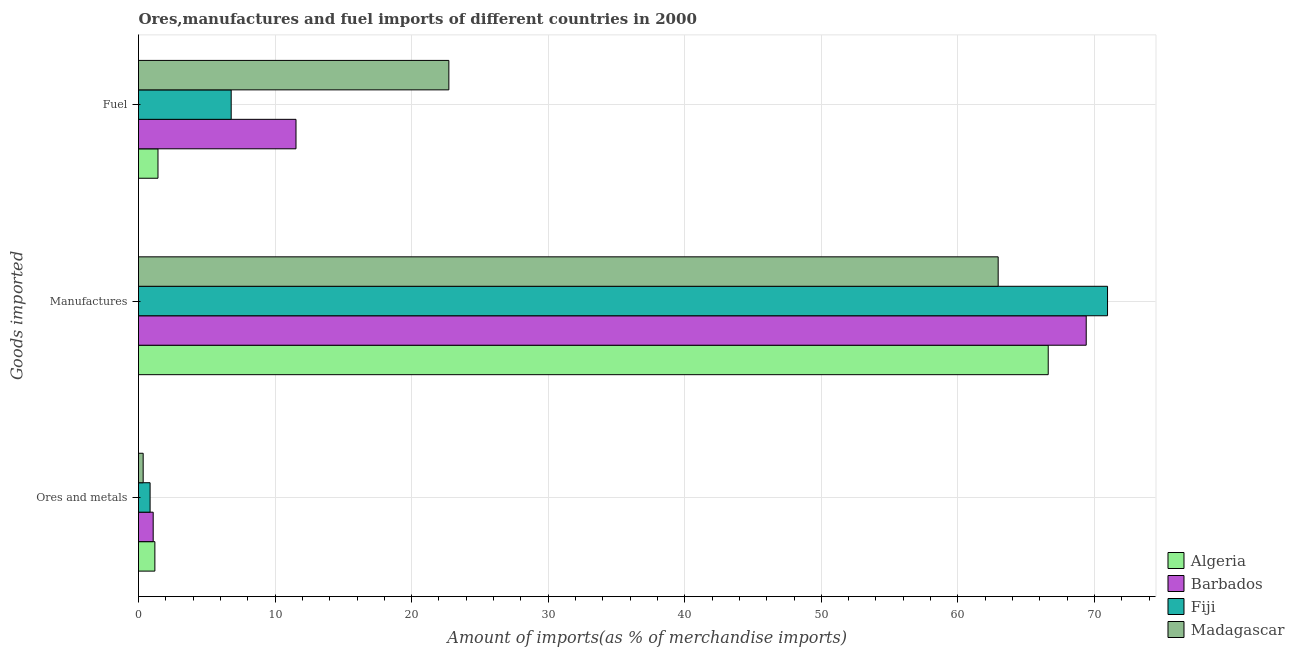Are the number of bars per tick equal to the number of legend labels?
Make the answer very short. Yes. How many bars are there on the 1st tick from the top?
Give a very brief answer. 4. What is the label of the 3rd group of bars from the top?
Give a very brief answer. Ores and metals. What is the percentage of ores and metals imports in Algeria?
Provide a succinct answer. 1.2. Across all countries, what is the maximum percentage of fuel imports?
Your answer should be very brief. 22.73. Across all countries, what is the minimum percentage of fuel imports?
Provide a succinct answer. 1.43. In which country was the percentage of fuel imports maximum?
Your answer should be very brief. Madagascar. In which country was the percentage of ores and metals imports minimum?
Make the answer very short. Madagascar. What is the total percentage of fuel imports in the graph?
Keep it short and to the point. 42.47. What is the difference between the percentage of manufactures imports in Fiji and that in Madagascar?
Give a very brief answer. 8.01. What is the difference between the percentage of manufactures imports in Madagascar and the percentage of fuel imports in Barbados?
Your answer should be compact. 51.42. What is the average percentage of manufactures imports per country?
Provide a short and direct response. 67.48. What is the difference between the percentage of fuel imports and percentage of manufactures imports in Fiji?
Your response must be concise. -64.17. In how many countries, is the percentage of fuel imports greater than 46 %?
Offer a terse response. 0. What is the ratio of the percentage of fuel imports in Madagascar to that in Algeria?
Offer a terse response. 15.93. Is the difference between the percentage of manufactures imports in Barbados and Fiji greater than the difference between the percentage of fuel imports in Barbados and Fiji?
Your answer should be very brief. No. What is the difference between the highest and the second highest percentage of ores and metals imports?
Your answer should be compact. 0.12. What is the difference between the highest and the lowest percentage of fuel imports?
Give a very brief answer. 21.3. Is the sum of the percentage of manufactures imports in Algeria and Fiji greater than the maximum percentage of fuel imports across all countries?
Provide a succinct answer. Yes. What does the 2nd bar from the top in Fuel represents?
Your answer should be compact. Fiji. What does the 2nd bar from the bottom in Ores and metals represents?
Give a very brief answer. Barbados. How many bars are there?
Give a very brief answer. 12. Are all the bars in the graph horizontal?
Make the answer very short. Yes. How many countries are there in the graph?
Offer a terse response. 4. Does the graph contain any zero values?
Offer a terse response. No. How are the legend labels stacked?
Your answer should be compact. Vertical. What is the title of the graph?
Your answer should be compact. Ores,manufactures and fuel imports of different countries in 2000. What is the label or title of the X-axis?
Offer a terse response. Amount of imports(as % of merchandise imports). What is the label or title of the Y-axis?
Provide a short and direct response. Goods imported. What is the Amount of imports(as % of merchandise imports) in Algeria in Ores and metals?
Give a very brief answer. 1.2. What is the Amount of imports(as % of merchandise imports) in Barbados in Ores and metals?
Keep it short and to the point. 1.07. What is the Amount of imports(as % of merchandise imports) in Fiji in Ores and metals?
Ensure brevity in your answer.  0.85. What is the Amount of imports(as % of merchandise imports) in Madagascar in Ores and metals?
Your answer should be compact. 0.34. What is the Amount of imports(as % of merchandise imports) of Algeria in Manufactures?
Offer a very short reply. 66.61. What is the Amount of imports(as % of merchandise imports) of Barbados in Manufactures?
Give a very brief answer. 69.4. What is the Amount of imports(as % of merchandise imports) in Fiji in Manufactures?
Keep it short and to the point. 70.96. What is the Amount of imports(as % of merchandise imports) of Madagascar in Manufactures?
Give a very brief answer. 62.95. What is the Amount of imports(as % of merchandise imports) of Algeria in Fuel?
Your answer should be compact. 1.43. What is the Amount of imports(as % of merchandise imports) in Barbados in Fuel?
Ensure brevity in your answer.  11.53. What is the Amount of imports(as % of merchandise imports) in Fiji in Fuel?
Your response must be concise. 6.79. What is the Amount of imports(as % of merchandise imports) in Madagascar in Fuel?
Your answer should be compact. 22.73. Across all Goods imported, what is the maximum Amount of imports(as % of merchandise imports) of Algeria?
Provide a short and direct response. 66.61. Across all Goods imported, what is the maximum Amount of imports(as % of merchandise imports) of Barbados?
Keep it short and to the point. 69.4. Across all Goods imported, what is the maximum Amount of imports(as % of merchandise imports) of Fiji?
Provide a succinct answer. 70.96. Across all Goods imported, what is the maximum Amount of imports(as % of merchandise imports) of Madagascar?
Your answer should be very brief. 62.95. Across all Goods imported, what is the minimum Amount of imports(as % of merchandise imports) of Algeria?
Provide a succinct answer. 1.2. Across all Goods imported, what is the minimum Amount of imports(as % of merchandise imports) of Barbados?
Your answer should be compact. 1.07. Across all Goods imported, what is the minimum Amount of imports(as % of merchandise imports) of Fiji?
Provide a short and direct response. 0.85. Across all Goods imported, what is the minimum Amount of imports(as % of merchandise imports) of Madagascar?
Ensure brevity in your answer.  0.34. What is the total Amount of imports(as % of merchandise imports) of Algeria in the graph?
Offer a terse response. 69.24. What is the total Amount of imports(as % of merchandise imports) in Barbados in the graph?
Make the answer very short. 82. What is the total Amount of imports(as % of merchandise imports) in Fiji in the graph?
Give a very brief answer. 78.59. What is the total Amount of imports(as % of merchandise imports) in Madagascar in the graph?
Provide a short and direct response. 86.02. What is the difference between the Amount of imports(as % of merchandise imports) of Algeria in Ores and metals and that in Manufactures?
Provide a succinct answer. -65.42. What is the difference between the Amount of imports(as % of merchandise imports) of Barbados in Ores and metals and that in Manufactures?
Give a very brief answer. -68.32. What is the difference between the Amount of imports(as % of merchandise imports) in Fiji in Ores and metals and that in Manufactures?
Keep it short and to the point. -70.11. What is the difference between the Amount of imports(as % of merchandise imports) of Madagascar in Ores and metals and that in Manufactures?
Your answer should be very brief. -62.61. What is the difference between the Amount of imports(as % of merchandise imports) in Algeria in Ores and metals and that in Fuel?
Provide a succinct answer. -0.23. What is the difference between the Amount of imports(as % of merchandise imports) of Barbados in Ores and metals and that in Fuel?
Ensure brevity in your answer.  -10.46. What is the difference between the Amount of imports(as % of merchandise imports) in Fiji in Ores and metals and that in Fuel?
Your answer should be very brief. -5.94. What is the difference between the Amount of imports(as % of merchandise imports) in Madagascar in Ores and metals and that in Fuel?
Your answer should be very brief. -22.38. What is the difference between the Amount of imports(as % of merchandise imports) of Algeria in Manufactures and that in Fuel?
Offer a terse response. 65.19. What is the difference between the Amount of imports(as % of merchandise imports) of Barbados in Manufactures and that in Fuel?
Provide a succinct answer. 57.86. What is the difference between the Amount of imports(as % of merchandise imports) of Fiji in Manufactures and that in Fuel?
Ensure brevity in your answer.  64.17. What is the difference between the Amount of imports(as % of merchandise imports) of Madagascar in Manufactures and that in Fuel?
Keep it short and to the point. 40.22. What is the difference between the Amount of imports(as % of merchandise imports) of Algeria in Ores and metals and the Amount of imports(as % of merchandise imports) of Barbados in Manufactures?
Your answer should be compact. -68.2. What is the difference between the Amount of imports(as % of merchandise imports) of Algeria in Ores and metals and the Amount of imports(as % of merchandise imports) of Fiji in Manufactures?
Ensure brevity in your answer.  -69.76. What is the difference between the Amount of imports(as % of merchandise imports) in Algeria in Ores and metals and the Amount of imports(as % of merchandise imports) in Madagascar in Manufactures?
Keep it short and to the point. -61.75. What is the difference between the Amount of imports(as % of merchandise imports) of Barbados in Ores and metals and the Amount of imports(as % of merchandise imports) of Fiji in Manufactures?
Make the answer very short. -69.88. What is the difference between the Amount of imports(as % of merchandise imports) of Barbados in Ores and metals and the Amount of imports(as % of merchandise imports) of Madagascar in Manufactures?
Your answer should be very brief. -61.88. What is the difference between the Amount of imports(as % of merchandise imports) in Fiji in Ores and metals and the Amount of imports(as % of merchandise imports) in Madagascar in Manufactures?
Provide a succinct answer. -62.1. What is the difference between the Amount of imports(as % of merchandise imports) in Algeria in Ores and metals and the Amount of imports(as % of merchandise imports) in Barbados in Fuel?
Offer a terse response. -10.33. What is the difference between the Amount of imports(as % of merchandise imports) in Algeria in Ores and metals and the Amount of imports(as % of merchandise imports) in Fiji in Fuel?
Your answer should be very brief. -5.59. What is the difference between the Amount of imports(as % of merchandise imports) in Algeria in Ores and metals and the Amount of imports(as % of merchandise imports) in Madagascar in Fuel?
Offer a terse response. -21.53. What is the difference between the Amount of imports(as % of merchandise imports) in Barbados in Ores and metals and the Amount of imports(as % of merchandise imports) in Fiji in Fuel?
Provide a succinct answer. -5.71. What is the difference between the Amount of imports(as % of merchandise imports) of Barbados in Ores and metals and the Amount of imports(as % of merchandise imports) of Madagascar in Fuel?
Offer a terse response. -21.65. What is the difference between the Amount of imports(as % of merchandise imports) of Fiji in Ores and metals and the Amount of imports(as % of merchandise imports) of Madagascar in Fuel?
Provide a succinct answer. -21.88. What is the difference between the Amount of imports(as % of merchandise imports) in Algeria in Manufactures and the Amount of imports(as % of merchandise imports) in Barbados in Fuel?
Provide a short and direct response. 55.08. What is the difference between the Amount of imports(as % of merchandise imports) of Algeria in Manufactures and the Amount of imports(as % of merchandise imports) of Fiji in Fuel?
Offer a terse response. 59.83. What is the difference between the Amount of imports(as % of merchandise imports) in Algeria in Manufactures and the Amount of imports(as % of merchandise imports) in Madagascar in Fuel?
Ensure brevity in your answer.  43.89. What is the difference between the Amount of imports(as % of merchandise imports) in Barbados in Manufactures and the Amount of imports(as % of merchandise imports) in Fiji in Fuel?
Provide a short and direct response. 62.61. What is the difference between the Amount of imports(as % of merchandise imports) of Barbados in Manufactures and the Amount of imports(as % of merchandise imports) of Madagascar in Fuel?
Your answer should be very brief. 46.67. What is the difference between the Amount of imports(as % of merchandise imports) in Fiji in Manufactures and the Amount of imports(as % of merchandise imports) in Madagascar in Fuel?
Keep it short and to the point. 48.23. What is the average Amount of imports(as % of merchandise imports) of Algeria per Goods imported?
Provide a short and direct response. 23.08. What is the average Amount of imports(as % of merchandise imports) in Barbados per Goods imported?
Ensure brevity in your answer.  27.33. What is the average Amount of imports(as % of merchandise imports) in Fiji per Goods imported?
Make the answer very short. 26.2. What is the average Amount of imports(as % of merchandise imports) in Madagascar per Goods imported?
Provide a short and direct response. 28.67. What is the difference between the Amount of imports(as % of merchandise imports) in Algeria and Amount of imports(as % of merchandise imports) in Barbados in Ores and metals?
Your answer should be compact. 0.12. What is the difference between the Amount of imports(as % of merchandise imports) in Algeria and Amount of imports(as % of merchandise imports) in Fiji in Ores and metals?
Offer a terse response. 0.35. What is the difference between the Amount of imports(as % of merchandise imports) in Algeria and Amount of imports(as % of merchandise imports) in Madagascar in Ores and metals?
Ensure brevity in your answer.  0.86. What is the difference between the Amount of imports(as % of merchandise imports) in Barbados and Amount of imports(as % of merchandise imports) in Fiji in Ores and metals?
Keep it short and to the point. 0.23. What is the difference between the Amount of imports(as % of merchandise imports) of Barbados and Amount of imports(as % of merchandise imports) of Madagascar in Ores and metals?
Make the answer very short. 0.73. What is the difference between the Amount of imports(as % of merchandise imports) in Fiji and Amount of imports(as % of merchandise imports) in Madagascar in Ores and metals?
Your answer should be very brief. 0.51. What is the difference between the Amount of imports(as % of merchandise imports) of Algeria and Amount of imports(as % of merchandise imports) of Barbados in Manufactures?
Your response must be concise. -2.78. What is the difference between the Amount of imports(as % of merchandise imports) of Algeria and Amount of imports(as % of merchandise imports) of Fiji in Manufactures?
Offer a very short reply. -4.34. What is the difference between the Amount of imports(as % of merchandise imports) in Algeria and Amount of imports(as % of merchandise imports) in Madagascar in Manufactures?
Your response must be concise. 3.67. What is the difference between the Amount of imports(as % of merchandise imports) in Barbados and Amount of imports(as % of merchandise imports) in Fiji in Manufactures?
Make the answer very short. -1.56. What is the difference between the Amount of imports(as % of merchandise imports) of Barbados and Amount of imports(as % of merchandise imports) of Madagascar in Manufactures?
Your answer should be compact. 6.45. What is the difference between the Amount of imports(as % of merchandise imports) of Fiji and Amount of imports(as % of merchandise imports) of Madagascar in Manufactures?
Your answer should be compact. 8.01. What is the difference between the Amount of imports(as % of merchandise imports) in Algeria and Amount of imports(as % of merchandise imports) in Barbados in Fuel?
Keep it short and to the point. -10.11. What is the difference between the Amount of imports(as % of merchandise imports) of Algeria and Amount of imports(as % of merchandise imports) of Fiji in Fuel?
Provide a succinct answer. -5.36. What is the difference between the Amount of imports(as % of merchandise imports) of Algeria and Amount of imports(as % of merchandise imports) of Madagascar in Fuel?
Make the answer very short. -21.3. What is the difference between the Amount of imports(as % of merchandise imports) of Barbados and Amount of imports(as % of merchandise imports) of Fiji in Fuel?
Ensure brevity in your answer.  4.75. What is the difference between the Amount of imports(as % of merchandise imports) of Barbados and Amount of imports(as % of merchandise imports) of Madagascar in Fuel?
Give a very brief answer. -11.19. What is the difference between the Amount of imports(as % of merchandise imports) of Fiji and Amount of imports(as % of merchandise imports) of Madagascar in Fuel?
Your answer should be very brief. -15.94. What is the ratio of the Amount of imports(as % of merchandise imports) in Algeria in Ores and metals to that in Manufactures?
Make the answer very short. 0.02. What is the ratio of the Amount of imports(as % of merchandise imports) of Barbados in Ores and metals to that in Manufactures?
Provide a succinct answer. 0.02. What is the ratio of the Amount of imports(as % of merchandise imports) in Fiji in Ores and metals to that in Manufactures?
Your response must be concise. 0.01. What is the ratio of the Amount of imports(as % of merchandise imports) in Madagascar in Ores and metals to that in Manufactures?
Your response must be concise. 0.01. What is the ratio of the Amount of imports(as % of merchandise imports) in Algeria in Ores and metals to that in Fuel?
Provide a succinct answer. 0.84. What is the ratio of the Amount of imports(as % of merchandise imports) of Barbados in Ores and metals to that in Fuel?
Your answer should be very brief. 0.09. What is the ratio of the Amount of imports(as % of merchandise imports) in Fiji in Ores and metals to that in Fuel?
Offer a very short reply. 0.12. What is the ratio of the Amount of imports(as % of merchandise imports) in Madagascar in Ores and metals to that in Fuel?
Make the answer very short. 0.01. What is the ratio of the Amount of imports(as % of merchandise imports) of Algeria in Manufactures to that in Fuel?
Offer a terse response. 46.7. What is the ratio of the Amount of imports(as % of merchandise imports) in Barbados in Manufactures to that in Fuel?
Your response must be concise. 6.02. What is the ratio of the Amount of imports(as % of merchandise imports) of Fiji in Manufactures to that in Fuel?
Provide a short and direct response. 10.45. What is the ratio of the Amount of imports(as % of merchandise imports) in Madagascar in Manufactures to that in Fuel?
Make the answer very short. 2.77. What is the difference between the highest and the second highest Amount of imports(as % of merchandise imports) in Algeria?
Offer a very short reply. 65.19. What is the difference between the highest and the second highest Amount of imports(as % of merchandise imports) in Barbados?
Offer a very short reply. 57.86. What is the difference between the highest and the second highest Amount of imports(as % of merchandise imports) in Fiji?
Offer a terse response. 64.17. What is the difference between the highest and the second highest Amount of imports(as % of merchandise imports) of Madagascar?
Your answer should be compact. 40.22. What is the difference between the highest and the lowest Amount of imports(as % of merchandise imports) of Algeria?
Keep it short and to the point. 65.42. What is the difference between the highest and the lowest Amount of imports(as % of merchandise imports) of Barbados?
Offer a very short reply. 68.32. What is the difference between the highest and the lowest Amount of imports(as % of merchandise imports) of Fiji?
Provide a succinct answer. 70.11. What is the difference between the highest and the lowest Amount of imports(as % of merchandise imports) in Madagascar?
Give a very brief answer. 62.61. 